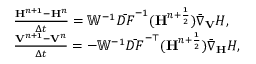<formula> <loc_0><loc_0><loc_500><loc_500>\begin{array} { r l } & { \frac { { \mathbf H } ^ { n + 1 } - { \mathbf H } ^ { n } } { \Delta t } = { \mathbb { W } } ^ { - 1 } \bar { D F } ^ { - 1 } ( { \mathbf H } ^ { n + \frac { 1 } { 2 } } ) \bar { \nabla } _ { V } H , } \\ & { \frac { { \mathbf V } ^ { n + 1 } - { \mathbf V } ^ { n } } { \Delta t } = - { \mathbb { W } } ^ { - 1 } \bar { D F } ^ { - \top } ( { \mathbf H } ^ { n + \frac { 1 } { 2 } } ) \bar { \nabla } _ { H } H , } \end{array}</formula> 